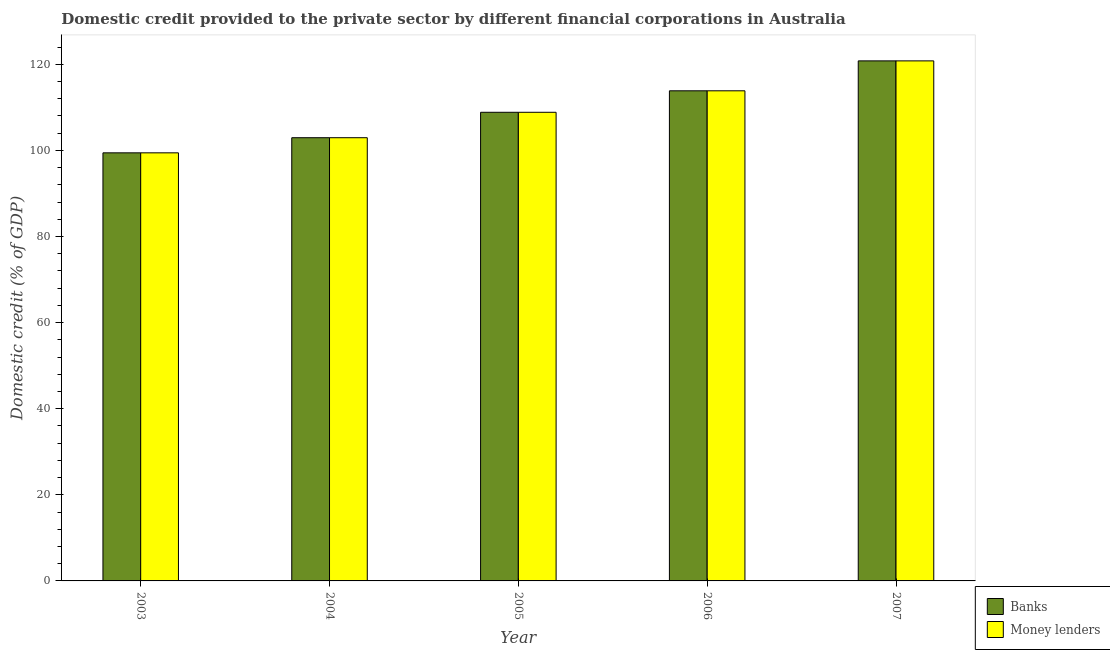How many different coloured bars are there?
Offer a terse response. 2. How many groups of bars are there?
Make the answer very short. 5. Are the number of bars per tick equal to the number of legend labels?
Provide a short and direct response. Yes. How many bars are there on the 3rd tick from the right?
Offer a terse response. 2. What is the label of the 2nd group of bars from the left?
Provide a succinct answer. 2004. In how many cases, is the number of bars for a given year not equal to the number of legend labels?
Give a very brief answer. 0. What is the domestic credit provided by money lenders in 2003?
Keep it short and to the point. 99.43. Across all years, what is the maximum domestic credit provided by money lenders?
Offer a terse response. 120.79. Across all years, what is the minimum domestic credit provided by money lenders?
Ensure brevity in your answer.  99.43. In which year was the domestic credit provided by money lenders maximum?
Give a very brief answer. 2007. What is the total domestic credit provided by banks in the graph?
Keep it short and to the point. 545.84. What is the difference between the domestic credit provided by banks in 2003 and that in 2006?
Give a very brief answer. -14.4. What is the difference between the domestic credit provided by banks in 2005 and the domestic credit provided by money lenders in 2004?
Provide a succinct answer. 5.91. What is the average domestic credit provided by banks per year?
Your response must be concise. 109.17. In the year 2006, what is the difference between the domestic credit provided by money lenders and domestic credit provided by banks?
Provide a succinct answer. 0. In how many years, is the domestic credit provided by money lenders greater than 80 %?
Keep it short and to the point. 5. What is the ratio of the domestic credit provided by banks in 2004 to that in 2006?
Offer a very short reply. 0.9. Is the domestic credit provided by money lenders in 2005 less than that in 2007?
Provide a succinct answer. Yes. What is the difference between the highest and the second highest domestic credit provided by money lenders?
Keep it short and to the point. 6.95. What is the difference between the highest and the lowest domestic credit provided by banks?
Give a very brief answer. 21.36. What does the 2nd bar from the left in 2005 represents?
Ensure brevity in your answer.  Money lenders. What does the 1st bar from the right in 2003 represents?
Give a very brief answer. Money lenders. Does the graph contain any zero values?
Provide a succinct answer. No. How many legend labels are there?
Provide a succinct answer. 2. How are the legend labels stacked?
Your answer should be compact. Vertical. What is the title of the graph?
Your answer should be compact. Domestic credit provided to the private sector by different financial corporations in Australia. Does "Frequency of shipment arrival" appear as one of the legend labels in the graph?
Your answer should be very brief. No. What is the label or title of the Y-axis?
Provide a short and direct response. Domestic credit (% of GDP). What is the Domestic credit (% of GDP) of Banks in 2003?
Offer a terse response. 99.43. What is the Domestic credit (% of GDP) in Money lenders in 2003?
Offer a very short reply. 99.43. What is the Domestic credit (% of GDP) of Banks in 2004?
Keep it short and to the point. 102.94. What is the Domestic credit (% of GDP) of Money lenders in 2004?
Give a very brief answer. 102.94. What is the Domestic credit (% of GDP) in Banks in 2005?
Keep it short and to the point. 108.85. What is the Domestic credit (% of GDP) of Money lenders in 2005?
Ensure brevity in your answer.  108.85. What is the Domestic credit (% of GDP) of Banks in 2006?
Give a very brief answer. 113.84. What is the Domestic credit (% of GDP) of Money lenders in 2006?
Keep it short and to the point. 113.84. What is the Domestic credit (% of GDP) of Banks in 2007?
Provide a short and direct response. 120.79. What is the Domestic credit (% of GDP) in Money lenders in 2007?
Your answer should be very brief. 120.79. Across all years, what is the maximum Domestic credit (% of GDP) of Banks?
Offer a very short reply. 120.79. Across all years, what is the maximum Domestic credit (% of GDP) in Money lenders?
Make the answer very short. 120.79. Across all years, what is the minimum Domestic credit (% of GDP) in Banks?
Ensure brevity in your answer.  99.43. Across all years, what is the minimum Domestic credit (% of GDP) in Money lenders?
Your answer should be very brief. 99.43. What is the total Domestic credit (% of GDP) in Banks in the graph?
Provide a short and direct response. 545.84. What is the total Domestic credit (% of GDP) in Money lenders in the graph?
Offer a terse response. 545.84. What is the difference between the Domestic credit (% of GDP) in Banks in 2003 and that in 2004?
Offer a terse response. -3.51. What is the difference between the Domestic credit (% of GDP) in Money lenders in 2003 and that in 2004?
Your answer should be very brief. -3.51. What is the difference between the Domestic credit (% of GDP) in Banks in 2003 and that in 2005?
Keep it short and to the point. -9.42. What is the difference between the Domestic credit (% of GDP) of Money lenders in 2003 and that in 2005?
Your response must be concise. -9.42. What is the difference between the Domestic credit (% of GDP) in Banks in 2003 and that in 2006?
Your answer should be very brief. -14.4. What is the difference between the Domestic credit (% of GDP) of Money lenders in 2003 and that in 2006?
Ensure brevity in your answer.  -14.4. What is the difference between the Domestic credit (% of GDP) in Banks in 2003 and that in 2007?
Your answer should be very brief. -21.36. What is the difference between the Domestic credit (% of GDP) in Money lenders in 2003 and that in 2007?
Give a very brief answer. -21.36. What is the difference between the Domestic credit (% of GDP) in Banks in 2004 and that in 2005?
Ensure brevity in your answer.  -5.91. What is the difference between the Domestic credit (% of GDP) of Money lenders in 2004 and that in 2005?
Make the answer very short. -5.91. What is the difference between the Domestic credit (% of GDP) of Banks in 2004 and that in 2006?
Provide a succinct answer. -10.89. What is the difference between the Domestic credit (% of GDP) in Money lenders in 2004 and that in 2006?
Keep it short and to the point. -10.89. What is the difference between the Domestic credit (% of GDP) in Banks in 2004 and that in 2007?
Your answer should be very brief. -17.85. What is the difference between the Domestic credit (% of GDP) in Money lenders in 2004 and that in 2007?
Keep it short and to the point. -17.85. What is the difference between the Domestic credit (% of GDP) in Banks in 2005 and that in 2006?
Provide a short and direct response. -4.99. What is the difference between the Domestic credit (% of GDP) of Money lenders in 2005 and that in 2006?
Your response must be concise. -4.99. What is the difference between the Domestic credit (% of GDP) of Banks in 2005 and that in 2007?
Provide a short and direct response. -11.94. What is the difference between the Domestic credit (% of GDP) in Money lenders in 2005 and that in 2007?
Give a very brief answer. -11.94. What is the difference between the Domestic credit (% of GDP) of Banks in 2006 and that in 2007?
Give a very brief answer. -6.95. What is the difference between the Domestic credit (% of GDP) of Money lenders in 2006 and that in 2007?
Give a very brief answer. -6.95. What is the difference between the Domestic credit (% of GDP) in Banks in 2003 and the Domestic credit (% of GDP) in Money lenders in 2004?
Give a very brief answer. -3.51. What is the difference between the Domestic credit (% of GDP) of Banks in 2003 and the Domestic credit (% of GDP) of Money lenders in 2005?
Provide a succinct answer. -9.42. What is the difference between the Domestic credit (% of GDP) of Banks in 2003 and the Domestic credit (% of GDP) of Money lenders in 2006?
Offer a terse response. -14.4. What is the difference between the Domestic credit (% of GDP) in Banks in 2003 and the Domestic credit (% of GDP) in Money lenders in 2007?
Keep it short and to the point. -21.36. What is the difference between the Domestic credit (% of GDP) in Banks in 2004 and the Domestic credit (% of GDP) in Money lenders in 2005?
Ensure brevity in your answer.  -5.91. What is the difference between the Domestic credit (% of GDP) in Banks in 2004 and the Domestic credit (% of GDP) in Money lenders in 2006?
Your response must be concise. -10.89. What is the difference between the Domestic credit (% of GDP) in Banks in 2004 and the Domestic credit (% of GDP) in Money lenders in 2007?
Make the answer very short. -17.85. What is the difference between the Domestic credit (% of GDP) of Banks in 2005 and the Domestic credit (% of GDP) of Money lenders in 2006?
Give a very brief answer. -4.99. What is the difference between the Domestic credit (% of GDP) of Banks in 2005 and the Domestic credit (% of GDP) of Money lenders in 2007?
Your response must be concise. -11.94. What is the difference between the Domestic credit (% of GDP) of Banks in 2006 and the Domestic credit (% of GDP) of Money lenders in 2007?
Provide a short and direct response. -6.95. What is the average Domestic credit (% of GDP) of Banks per year?
Ensure brevity in your answer.  109.17. What is the average Domestic credit (% of GDP) in Money lenders per year?
Your answer should be compact. 109.17. In the year 2003, what is the difference between the Domestic credit (% of GDP) of Banks and Domestic credit (% of GDP) of Money lenders?
Give a very brief answer. 0. In the year 2005, what is the difference between the Domestic credit (% of GDP) in Banks and Domestic credit (% of GDP) in Money lenders?
Provide a short and direct response. 0. What is the ratio of the Domestic credit (% of GDP) in Banks in 2003 to that in 2004?
Ensure brevity in your answer.  0.97. What is the ratio of the Domestic credit (% of GDP) of Money lenders in 2003 to that in 2004?
Provide a short and direct response. 0.97. What is the ratio of the Domestic credit (% of GDP) in Banks in 2003 to that in 2005?
Give a very brief answer. 0.91. What is the ratio of the Domestic credit (% of GDP) of Money lenders in 2003 to that in 2005?
Provide a short and direct response. 0.91. What is the ratio of the Domestic credit (% of GDP) of Banks in 2003 to that in 2006?
Make the answer very short. 0.87. What is the ratio of the Domestic credit (% of GDP) of Money lenders in 2003 to that in 2006?
Your response must be concise. 0.87. What is the ratio of the Domestic credit (% of GDP) of Banks in 2003 to that in 2007?
Keep it short and to the point. 0.82. What is the ratio of the Domestic credit (% of GDP) in Money lenders in 2003 to that in 2007?
Offer a very short reply. 0.82. What is the ratio of the Domestic credit (% of GDP) in Banks in 2004 to that in 2005?
Keep it short and to the point. 0.95. What is the ratio of the Domestic credit (% of GDP) of Money lenders in 2004 to that in 2005?
Your answer should be very brief. 0.95. What is the ratio of the Domestic credit (% of GDP) in Banks in 2004 to that in 2006?
Provide a short and direct response. 0.9. What is the ratio of the Domestic credit (% of GDP) in Money lenders in 2004 to that in 2006?
Give a very brief answer. 0.9. What is the ratio of the Domestic credit (% of GDP) of Banks in 2004 to that in 2007?
Ensure brevity in your answer.  0.85. What is the ratio of the Domestic credit (% of GDP) in Money lenders in 2004 to that in 2007?
Keep it short and to the point. 0.85. What is the ratio of the Domestic credit (% of GDP) in Banks in 2005 to that in 2006?
Your answer should be very brief. 0.96. What is the ratio of the Domestic credit (% of GDP) of Money lenders in 2005 to that in 2006?
Your answer should be compact. 0.96. What is the ratio of the Domestic credit (% of GDP) in Banks in 2005 to that in 2007?
Give a very brief answer. 0.9. What is the ratio of the Domestic credit (% of GDP) in Money lenders in 2005 to that in 2007?
Ensure brevity in your answer.  0.9. What is the ratio of the Domestic credit (% of GDP) of Banks in 2006 to that in 2007?
Your answer should be very brief. 0.94. What is the ratio of the Domestic credit (% of GDP) in Money lenders in 2006 to that in 2007?
Offer a terse response. 0.94. What is the difference between the highest and the second highest Domestic credit (% of GDP) of Banks?
Provide a succinct answer. 6.95. What is the difference between the highest and the second highest Domestic credit (% of GDP) in Money lenders?
Your answer should be very brief. 6.95. What is the difference between the highest and the lowest Domestic credit (% of GDP) in Banks?
Your answer should be very brief. 21.36. What is the difference between the highest and the lowest Domestic credit (% of GDP) in Money lenders?
Provide a short and direct response. 21.36. 